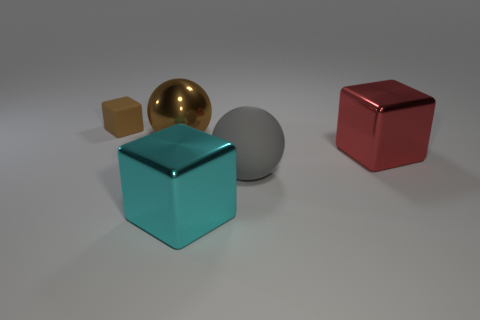What number of things are green rubber cylinders or blocks in front of the brown metallic thing?
Keep it short and to the point. 2. What is the size of the cube that is the same material as the gray ball?
Keep it short and to the point. Small. What shape is the large metallic thing that is in front of the rubber object that is in front of the brown matte block?
Provide a short and direct response. Cube. There is a block that is to the left of the large gray ball and in front of the big metallic sphere; what size is it?
Give a very brief answer. Large. Are there any other shiny objects that have the same shape as the large brown thing?
Provide a succinct answer. No. Is there anything else that has the same shape as the big red object?
Offer a very short reply. Yes. The large block that is in front of the large cube behind the ball in front of the big metal sphere is made of what material?
Keep it short and to the point. Metal. Is there a green cylinder that has the same size as the red object?
Your answer should be compact. No. The metal cube that is to the right of the metal cube that is in front of the big gray thing is what color?
Keep it short and to the point. Red. What number of large shiny blocks are there?
Your answer should be very brief. 2. 